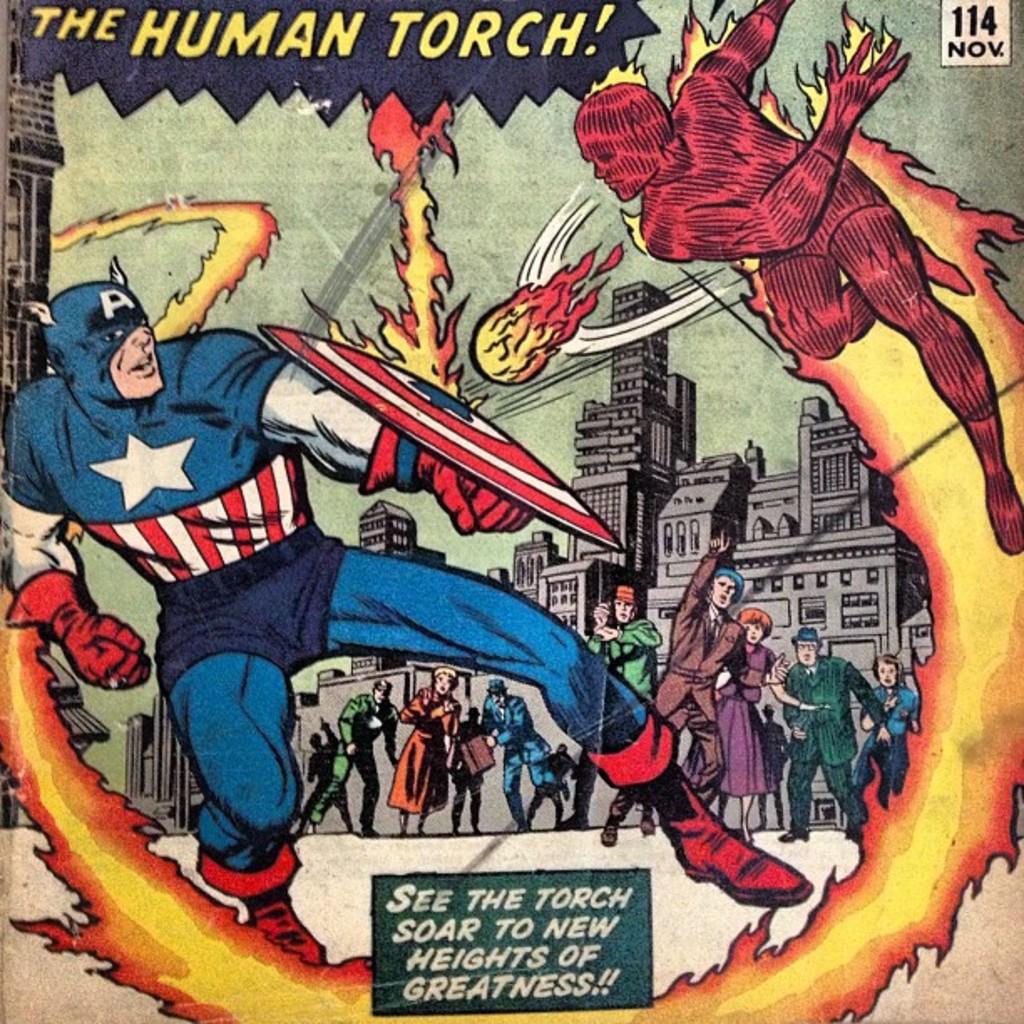What can we see the torch do?
Provide a short and direct response. Soar to new heights of greatness. The human what?
Provide a short and direct response. Torch. 